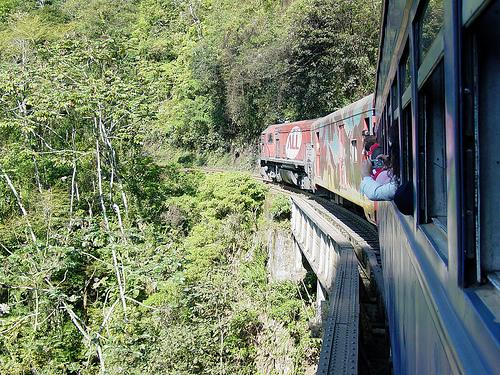In this image, describe the actions of the people on the train. People are leaning out of the train windows, with one person wearing a baseball cap, another holding a camera phone, and someone's arm extended outside of the train. Mention any notable objects a person is holding in the image. A person is holding a camera phone while capturing a picture. What emotions or feelings does this image convey? The image conveys a sense of adventure, excitement, and connection with nature as passengers enjoy their train journey amidst beautiful green scenery. Identify any artistic elements on the train. The train has a colorful car behind the engine, a white circle, a car with brown designs, red and white car, and a painting on the side. Describe the bridge on which the train is passing. The train is passing over a railroad bridge with wooden fence and tracks, surrounded by green trees. Count the train cars visible in the image. There are three train cars visible on the track. Analyze the interactions between people and objects in this image. People are interacting with their camera phones, the train windows, and items hanging outside of the train while leaning out of the windows to engage with their surroundings. Can you describe the state of the train windows in the image? The train windows are open, with passengers leaning out from them, and some items hanging outside. What can you gather from the image about the train and its surroundings? The image shows a red engine train with several colorful cars passing over a bridge surrounded by dense foliage of green trees, with people leaning out of the windows and taking pictures. How would you describe the environment around the train? The train is surrounded by a lush environment with numerous green trees, tall leafy branches, and a wooden fence on a bridge. 